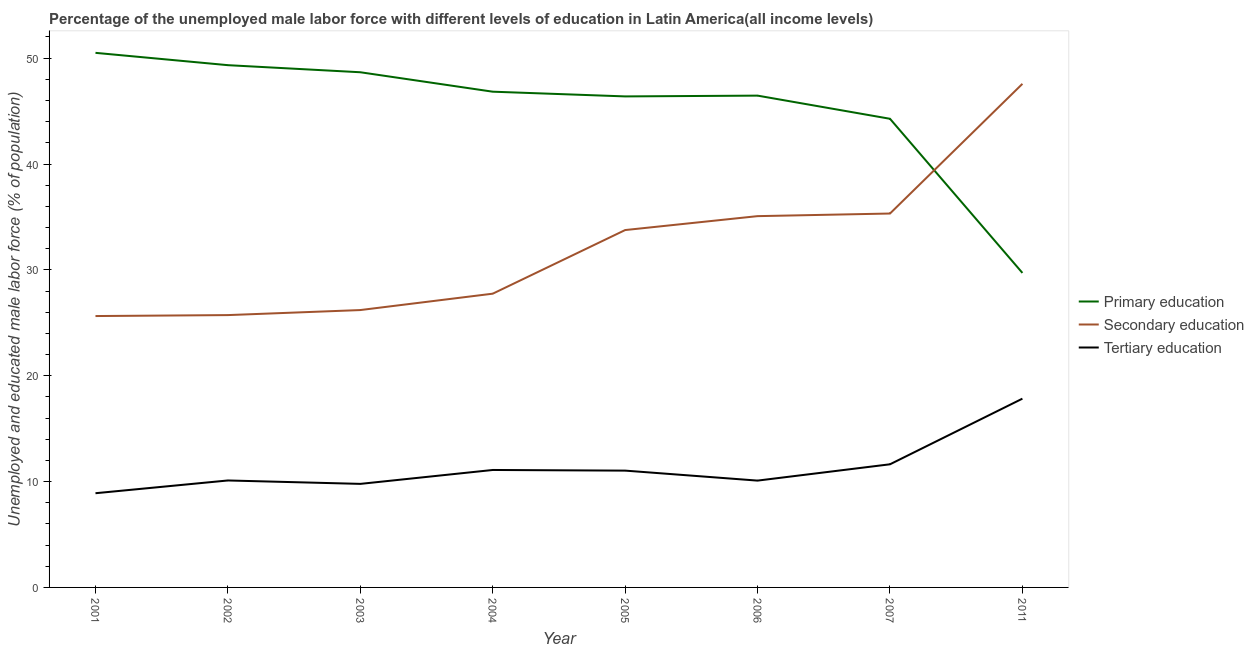How many different coloured lines are there?
Ensure brevity in your answer.  3. Does the line corresponding to percentage of male labor force who received primary education intersect with the line corresponding to percentage of male labor force who received tertiary education?
Ensure brevity in your answer.  No. Is the number of lines equal to the number of legend labels?
Keep it short and to the point. Yes. What is the percentage of male labor force who received primary education in 2003?
Offer a very short reply. 48.67. Across all years, what is the maximum percentage of male labor force who received secondary education?
Ensure brevity in your answer.  47.57. Across all years, what is the minimum percentage of male labor force who received tertiary education?
Keep it short and to the point. 8.9. In which year was the percentage of male labor force who received primary education minimum?
Offer a terse response. 2011. What is the total percentage of male labor force who received primary education in the graph?
Provide a short and direct response. 362.17. What is the difference between the percentage of male labor force who received tertiary education in 2004 and that in 2011?
Provide a succinct answer. -6.74. What is the difference between the percentage of male labor force who received tertiary education in 2007 and the percentage of male labor force who received secondary education in 2004?
Your response must be concise. -16.12. What is the average percentage of male labor force who received secondary education per year?
Give a very brief answer. 32.13. In the year 2004, what is the difference between the percentage of male labor force who received tertiary education and percentage of male labor force who received primary education?
Your answer should be very brief. -35.74. In how many years, is the percentage of male labor force who received tertiary education greater than 26 %?
Provide a short and direct response. 0. What is the ratio of the percentage of male labor force who received secondary education in 2003 to that in 2004?
Offer a very short reply. 0.94. Is the percentage of male labor force who received secondary education in 2002 less than that in 2004?
Provide a short and direct response. Yes. What is the difference between the highest and the second highest percentage of male labor force who received primary education?
Your answer should be compact. 1.16. What is the difference between the highest and the lowest percentage of male labor force who received primary education?
Your answer should be compact. 20.79. Is the sum of the percentage of male labor force who received tertiary education in 2002 and 2005 greater than the maximum percentage of male labor force who received secondary education across all years?
Offer a very short reply. No. Is it the case that in every year, the sum of the percentage of male labor force who received primary education and percentage of male labor force who received secondary education is greater than the percentage of male labor force who received tertiary education?
Offer a very short reply. Yes. Is the percentage of male labor force who received secondary education strictly greater than the percentage of male labor force who received primary education over the years?
Your response must be concise. No. Is the percentage of male labor force who received secondary education strictly less than the percentage of male labor force who received primary education over the years?
Offer a very short reply. No. How many years are there in the graph?
Keep it short and to the point. 8. Does the graph contain grids?
Provide a short and direct response. No. How many legend labels are there?
Provide a succinct answer. 3. What is the title of the graph?
Give a very brief answer. Percentage of the unemployed male labor force with different levels of education in Latin America(all income levels). What is the label or title of the X-axis?
Provide a succinct answer. Year. What is the label or title of the Y-axis?
Your answer should be compact. Unemployed and educated male labor force (% of population). What is the Unemployed and educated male labor force (% of population) of Primary education in 2001?
Ensure brevity in your answer.  50.5. What is the Unemployed and educated male labor force (% of population) of Secondary education in 2001?
Your response must be concise. 25.64. What is the Unemployed and educated male labor force (% of population) of Tertiary education in 2001?
Provide a succinct answer. 8.9. What is the Unemployed and educated male labor force (% of population) in Primary education in 2002?
Offer a terse response. 49.34. What is the Unemployed and educated male labor force (% of population) in Secondary education in 2002?
Give a very brief answer. 25.73. What is the Unemployed and educated male labor force (% of population) in Tertiary education in 2002?
Your answer should be very brief. 10.1. What is the Unemployed and educated male labor force (% of population) of Primary education in 2003?
Your answer should be very brief. 48.67. What is the Unemployed and educated male labor force (% of population) of Secondary education in 2003?
Offer a very short reply. 26.2. What is the Unemployed and educated male labor force (% of population) of Tertiary education in 2003?
Ensure brevity in your answer.  9.78. What is the Unemployed and educated male labor force (% of population) of Primary education in 2004?
Your answer should be compact. 46.83. What is the Unemployed and educated male labor force (% of population) in Secondary education in 2004?
Offer a terse response. 27.75. What is the Unemployed and educated male labor force (% of population) of Tertiary education in 2004?
Offer a very short reply. 11.1. What is the Unemployed and educated male labor force (% of population) in Primary education in 2005?
Your answer should be compact. 46.39. What is the Unemployed and educated male labor force (% of population) of Secondary education in 2005?
Give a very brief answer. 33.76. What is the Unemployed and educated male labor force (% of population) in Tertiary education in 2005?
Your answer should be compact. 11.03. What is the Unemployed and educated male labor force (% of population) of Primary education in 2006?
Your answer should be compact. 46.46. What is the Unemployed and educated male labor force (% of population) in Secondary education in 2006?
Your response must be concise. 35.08. What is the Unemployed and educated male labor force (% of population) in Tertiary education in 2006?
Your answer should be compact. 10.09. What is the Unemployed and educated male labor force (% of population) in Primary education in 2007?
Give a very brief answer. 44.27. What is the Unemployed and educated male labor force (% of population) in Secondary education in 2007?
Provide a short and direct response. 35.32. What is the Unemployed and educated male labor force (% of population) in Tertiary education in 2007?
Provide a short and direct response. 11.63. What is the Unemployed and educated male labor force (% of population) in Primary education in 2011?
Your answer should be compact. 29.71. What is the Unemployed and educated male labor force (% of population) of Secondary education in 2011?
Make the answer very short. 47.57. What is the Unemployed and educated male labor force (% of population) of Tertiary education in 2011?
Offer a terse response. 17.83. Across all years, what is the maximum Unemployed and educated male labor force (% of population) of Primary education?
Provide a succinct answer. 50.5. Across all years, what is the maximum Unemployed and educated male labor force (% of population) of Secondary education?
Make the answer very short. 47.57. Across all years, what is the maximum Unemployed and educated male labor force (% of population) in Tertiary education?
Your answer should be very brief. 17.83. Across all years, what is the minimum Unemployed and educated male labor force (% of population) of Primary education?
Ensure brevity in your answer.  29.71. Across all years, what is the minimum Unemployed and educated male labor force (% of population) in Secondary education?
Offer a terse response. 25.64. Across all years, what is the minimum Unemployed and educated male labor force (% of population) of Tertiary education?
Make the answer very short. 8.9. What is the total Unemployed and educated male labor force (% of population) of Primary education in the graph?
Your answer should be compact. 362.17. What is the total Unemployed and educated male labor force (% of population) of Secondary education in the graph?
Offer a very short reply. 257.05. What is the total Unemployed and educated male labor force (% of population) in Tertiary education in the graph?
Provide a succinct answer. 90.47. What is the difference between the Unemployed and educated male labor force (% of population) of Primary education in 2001 and that in 2002?
Ensure brevity in your answer.  1.16. What is the difference between the Unemployed and educated male labor force (% of population) in Secondary education in 2001 and that in 2002?
Offer a very short reply. -0.09. What is the difference between the Unemployed and educated male labor force (% of population) in Tertiary education in 2001 and that in 2002?
Ensure brevity in your answer.  -1.2. What is the difference between the Unemployed and educated male labor force (% of population) in Primary education in 2001 and that in 2003?
Keep it short and to the point. 1.83. What is the difference between the Unemployed and educated male labor force (% of population) in Secondary education in 2001 and that in 2003?
Provide a short and direct response. -0.57. What is the difference between the Unemployed and educated male labor force (% of population) of Tertiary education in 2001 and that in 2003?
Provide a succinct answer. -0.88. What is the difference between the Unemployed and educated male labor force (% of population) of Primary education in 2001 and that in 2004?
Give a very brief answer. 3.67. What is the difference between the Unemployed and educated male labor force (% of population) in Secondary education in 2001 and that in 2004?
Your response must be concise. -2.11. What is the difference between the Unemployed and educated male labor force (% of population) in Tertiary education in 2001 and that in 2004?
Provide a short and direct response. -2.2. What is the difference between the Unemployed and educated male labor force (% of population) of Primary education in 2001 and that in 2005?
Your response must be concise. 4.12. What is the difference between the Unemployed and educated male labor force (% of population) in Secondary education in 2001 and that in 2005?
Your answer should be compact. -8.12. What is the difference between the Unemployed and educated male labor force (% of population) of Tertiary education in 2001 and that in 2005?
Give a very brief answer. -2.13. What is the difference between the Unemployed and educated male labor force (% of population) of Primary education in 2001 and that in 2006?
Keep it short and to the point. 4.04. What is the difference between the Unemployed and educated male labor force (% of population) of Secondary education in 2001 and that in 2006?
Provide a succinct answer. -9.44. What is the difference between the Unemployed and educated male labor force (% of population) of Tertiary education in 2001 and that in 2006?
Your answer should be very brief. -1.19. What is the difference between the Unemployed and educated male labor force (% of population) of Primary education in 2001 and that in 2007?
Ensure brevity in your answer.  6.23. What is the difference between the Unemployed and educated male labor force (% of population) of Secondary education in 2001 and that in 2007?
Your answer should be compact. -9.69. What is the difference between the Unemployed and educated male labor force (% of population) in Tertiary education in 2001 and that in 2007?
Give a very brief answer. -2.73. What is the difference between the Unemployed and educated male labor force (% of population) in Primary education in 2001 and that in 2011?
Give a very brief answer. 20.79. What is the difference between the Unemployed and educated male labor force (% of population) of Secondary education in 2001 and that in 2011?
Provide a short and direct response. -21.94. What is the difference between the Unemployed and educated male labor force (% of population) in Tertiary education in 2001 and that in 2011?
Ensure brevity in your answer.  -8.93. What is the difference between the Unemployed and educated male labor force (% of population) of Primary education in 2002 and that in 2003?
Your answer should be very brief. 0.67. What is the difference between the Unemployed and educated male labor force (% of population) of Secondary education in 2002 and that in 2003?
Provide a succinct answer. -0.48. What is the difference between the Unemployed and educated male labor force (% of population) in Tertiary education in 2002 and that in 2003?
Give a very brief answer. 0.32. What is the difference between the Unemployed and educated male labor force (% of population) of Primary education in 2002 and that in 2004?
Your answer should be very brief. 2.51. What is the difference between the Unemployed and educated male labor force (% of population) of Secondary education in 2002 and that in 2004?
Keep it short and to the point. -2.02. What is the difference between the Unemployed and educated male labor force (% of population) of Tertiary education in 2002 and that in 2004?
Your answer should be very brief. -0.99. What is the difference between the Unemployed and educated male labor force (% of population) of Primary education in 2002 and that in 2005?
Ensure brevity in your answer.  2.95. What is the difference between the Unemployed and educated male labor force (% of population) in Secondary education in 2002 and that in 2005?
Give a very brief answer. -8.03. What is the difference between the Unemployed and educated male labor force (% of population) in Tertiary education in 2002 and that in 2005?
Ensure brevity in your answer.  -0.93. What is the difference between the Unemployed and educated male labor force (% of population) of Primary education in 2002 and that in 2006?
Your answer should be compact. 2.88. What is the difference between the Unemployed and educated male labor force (% of population) in Secondary education in 2002 and that in 2006?
Your answer should be very brief. -9.35. What is the difference between the Unemployed and educated male labor force (% of population) in Tertiary education in 2002 and that in 2006?
Provide a succinct answer. 0.01. What is the difference between the Unemployed and educated male labor force (% of population) in Primary education in 2002 and that in 2007?
Offer a terse response. 5.06. What is the difference between the Unemployed and educated male labor force (% of population) of Secondary education in 2002 and that in 2007?
Keep it short and to the point. -9.59. What is the difference between the Unemployed and educated male labor force (% of population) of Tertiary education in 2002 and that in 2007?
Provide a succinct answer. -1.53. What is the difference between the Unemployed and educated male labor force (% of population) of Primary education in 2002 and that in 2011?
Keep it short and to the point. 19.63. What is the difference between the Unemployed and educated male labor force (% of population) of Secondary education in 2002 and that in 2011?
Give a very brief answer. -21.85. What is the difference between the Unemployed and educated male labor force (% of population) in Tertiary education in 2002 and that in 2011?
Ensure brevity in your answer.  -7.73. What is the difference between the Unemployed and educated male labor force (% of population) of Primary education in 2003 and that in 2004?
Provide a short and direct response. 1.84. What is the difference between the Unemployed and educated male labor force (% of population) of Secondary education in 2003 and that in 2004?
Your answer should be compact. -1.55. What is the difference between the Unemployed and educated male labor force (% of population) of Tertiary education in 2003 and that in 2004?
Your response must be concise. -1.31. What is the difference between the Unemployed and educated male labor force (% of population) in Primary education in 2003 and that in 2005?
Offer a terse response. 2.28. What is the difference between the Unemployed and educated male labor force (% of population) of Secondary education in 2003 and that in 2005?
Offer a very short reply. -7.56. What is the difference between the Unemployed and educated male labor force (% of population) in Tertiary education in 2003 and that in 2005?
Ensure brevity in your answer.  -1.25. What is the difference between the Unemployed and educated male labor force (% of population) in Primary education in 2003 and that in 2006?
Your answer should be compact. 2.21. What is the difference between the Unemployed and educated male labor force (% of population) of Secondary education in 2003 and that in 2006?
Your answer should be compact. -8.87. What is the difference between the Unemployed and educated male labor force (% of population) in Tertiary education in 2003 and that in 2006?
Provide a short and direct response. -0.31. What is the difference between the Unemployed and educated male labor force (% of population) of Primary education in 2003 and that in 2007?
Your response must be concise. 4.4. What is the difference between the Unemployed and educated male labor force (% of population) of Secondary education in 2003 and that in 2007?
Ensure brevity in your answer.  -9.12. What is the difference between the Unemployed and educated male labor force (% of population) in Tertiary education in 2003 and that in 2007?
Your response must be concise. -1.85. What is the difference between the Unemployed and educated male labor force (% of population) of Primary education in 2003 and that in 2011?
Provide a succinct answer. 18.96. What is the difference between the Unemployed and educated male labor force (% of population) in Secondary education in 2003 and that in 2011?
Your answer should be very brief. -21.37. What is the difference between the Unemployed and educated male labor force (% of population) of Tertiary education in 2003 and that in 2011?
Provide a succinct answer. -8.05. What is the difference between the Unemployed and educated male labor force (% of population) of Primary education in 2004 and that in 2005?
Give a very brief answer. 0.45. What is the difference between the Unemployed and educated male labor force (% of population) of Secondary education in 2004 and that in 2005?
Provide a succinct answer. -6.01. What is the difference between the Unemployed and educated male labor force (% of population) in Tertiary education in 2004 and that in 2005?
Keep it short and to the point. 0.06. What is the difference between the Unemployed and educated male labor force (% of population) of Primary education in 2004 and that in 2006?
Offer a very short reply. 0.37. What is the difference between the Unemployed and educated male labor force (% of population) of Secondary education in 2004 and that in 2006?
Provide a succinct answer. -7.33. What is the difference between the Unemployed and educated male labor force (% of population) of Primary education in 2004 and that in 2007?
Your response must be concise. 2.56. What is the difference between the Unemployed and educated male labor force (% of population) in Secondary education in 2004 and that in 2007?
Your answer should be compact. -7.57. What is the difference between the Unemployed and educated male labor force (% of population) of Tertiary education in 2004 and that in 2007?
Make the answer very short. -0.54. What is the difference between the Unemployed and educated male labor force (% of population) of Primary education in 2004 and that in 2011?
Give a very brief answer. 17.12. What is the difference between the Unemployed and educated male labor force (% of population) of Secondary education in 2004 and that in 2011?
Your answer should be very brief. -19.82. What is the difference between the Unemployed and educated male labor force (% of population) of Tertiary education in 2004 and that in 2011?
Your response must be concise. -6.74. What is the difference between the Unemployed and educated male labor force (% of population) in Primary education in 2005 and that in 2006?
Provide a short and direct response. -0.07. What is the difference between the Unemployed and educated male labor force (% of population) of Secondary education in 2005 and that in 2006?
Offer a very short reply. -1.32. What is the difference between the Unemployed and educated male labor force (% of population) of Tertiary education in 2005 and that in 2006?
Make the answer very short. 0.94. What is the difference between the Unemployed and educated male labor force (% of population) in Primary education in 2005 and that in 2007?
Provide a succinct answer. 2.11. What is the difference between the Unemployed and educated male labor force (% of population) in Secondary education in 2005 and that in 2007?
Provide a short and direct response. -1.56. What is the difference between the Unemployed and educated male labor force (% of population) in Tertiary education in 2005 and that in 2007?
Your response must be concise. -0.6. What is the difference between the Unemployed and educated male labor force (% of population) of Primary education in 2005 and that in 2011?
Your response must be concise. 16.67. What is the difference between the Unemployed and educated male labor force (% of population) in Secondary education in 2005 and that in 2011?
Offer a very short reply. -13.81. What is the difference between the Unemployed and educated male labor force (% of population) in Tertiary education in 2005 and that in 2011?
Provide a short and direct response. -6.8. What is the difference between the Unemployed and educated male labor force (% of population) of Primary education in 2006 and that in 2007?
Your answer should be very brief. 2.19. What is the difference between the Unemployed and educated male labor force (% of population) of Secondary education in 2006 and that in 2007?
Offer a terse response. -0.25. What is the difference between the Unemployed and educated male labor force (% of population) of Tertiary education in 2006 and that in 2007?
Your answer should be very brief. -1.54. What is the difference between the Unemployed and educated male labor force (% of population) in Primary education in 2006 and that in 2011?
Provide a short and direct response. 16.75. What is the difference between the Unemployed and educated male labor force (% of population) in Secondary education in 2006 and that in 2011?
Your response must be concise. -12.5. What is the difference between the Unemployed and educated male labor force (% of population) in Tertiary education in 2006 and that in 2011?
Keep it short and to the point. -7.74. What is the difference between the Unemployed and educated male labor force (% of population) of Primary education in 2007 and that in 2011?
Make the answer very short. 14.56. What is the difference between the Unemployed and educated male labor force (% of population) of Secondary education in 2007 and that in 2011?
Give a very brief answer. -12.25. What is the difference between the Unemployed and educated male labor force (% of population) in Tertiary education in 2007 and that in 2011?
Your answer should be very brief. -6.2. What is the difference between the Unemployed and educated male labor force (% of population) in Primary education in 2001 and the Unemployed and educated male labor force (% of population) in Secondary education in 2002?
Provide a succinct answer. 24.77. What is the difference between the Unemployed and educated male labor force (% of population) of Primary education in 2001 and the Unemployed and educated male labor force (% of population) of Tertiary education in 2002?
Your response must be concise. 40.4. What is the difference between the Unemployed and educated male labor force (% of population) of Secondary education in 2001 and the Unemployed and educated male labor force (% of population) of Tertiary education in 2002?
Your response must be concise. 15.53. What is the difference between the Unemployed and educated male labor force (% of population) in Primary education in 2001 and the Unemployed and educated male labor force (% of population) in Secondary education in 2003?
Offer a terse response. 24.3. What is the difference between the Unemployed and educated male labor force (% of population) in Primary education in 2001 and the Unemployed and educated male labor force (% of population) in Tertiary education in 2003?
Ensure brevity in your answer.  40.72. What is the difference between the Unemployed and educated male labor force (% of population) in Secondary education in 2001 and the Unemployed and educated male labor force (% of population) in Tertiary education in 2003?
Ensure brevity in your answer.  15.86. What is the difference between the Unemployed and educated male labor force (% of population) of Primary education in 2001 and the Unemployed and educated male labor force (% of population) of Secondary education in 2004?
Offer a terse response. 22.75. What is the difference between the Unemployed and educated male labor force (% of population) of Primary education in 2001 and the Unemployed and educated male labor force (% of population) of Tertiary education in 2004?
Make the answer very short. 39.41. What is the difference between the Unemployed and educated male labor force (% of population) of Secondary education in 2001 and the Unemployed and educated male labor force (% of population) of Tertiary education in 2004?
Provide a succinct answer. 14.54. What is the difference between the Unemployed and educated male labor force (% of population) in Primary education in 2001 and the Unemployed and educated male labor force (% of population) in Secondary education in 2005?
Ensure brevity in your answer.  16.74. What is the difference between the Unemployed and educated male labor force (% of population) in Primary education in 2001 and the Unemployed and educated male labor force (% of population) in Tertiary education in 2005?
Make the answer very short. 39.47. What is the difference between the Unemployed and educated male labor force (% of population) of Secondary education in 2001 and the Unemployed and educated male labor force (% of population) of Tertiary education in 2005?
Give a very brief answer. 14.6. What is the difference between the Unemployed and educated male labor force (% of population) of Primary education in 2001 and the Unemployed and educated male labor force (% of population) of Secondary education in 2006?
Your answer should be very brief. 15.43. What is the difference between the Unemployed and educated male labor force (% of population) in Primary education in 2001 and the Unemployed and educated male labor force (% of population) in Tertiary education in 2006?
Keep it short and to the point. 40.41. What is the difference between the Unemployed and educated male labor force (% of population) in Secondary education in 2001 and the Unemployed and educated male labor force (% of population) in Tertiary education in 2006?
Make the answer very short. 15.55. What is the difference between the Unemployed and educated male labor force (% of population) in Primary education in 2001 and the Unemployed and educated male labor force (% of population) in Secondary education in 2007?
Your answer should be very brief. 15.18. What is the difference between the Unemployed and educated male labor force (% of population) in Primary education in 2001 and the Unemployed and educated male labor force (% of population) in Tertiary education in 2007?
Your response must be concise. 38.87. What is the difference between the Unemployed and educated male labor force (% of population) of Secondary education in 2001 and the Unemployed and educated male labor force (% of population) of Tertiary education in 2007?
Your answer should be very brief. 14.01. What is the difference between the Unemployed and educated male labor force (% of population) in Primary education in 2001 and the Unemployed and educated male labor force (% of population) in Secondary education in 2011?
Your answer should be very brief. 2.93. What is the difference between the Unemployed and educated male labor force (% of population) of Primary education in 2001 and the Unemployed and educated male labor force (% of population) of Tertiary education in 2011?
Offer a terse response. 32.67. What is the difference between the Unemployed and educated male labor force (% of population) of Secondary education in 2001 and the Unemployed and educated male labor force (% of population) of Tertiary education in 2011?
Your answer should be compact. 7.8. What is the difference between the Unemployed and educated male labor force (% of population) in Primary education in 2002 and the Unemployed and educated male labor force (% of population) in Secondary education in 2003?
Offer a very short reply. 23.13. What is the difference between the Unemployed and educated male labor force (% of population) of Primary education in 2002 and the Unemployed and educated male labor force (% of population) of Tertiary education in 2003?
Give a very brief answer. 39.56. What is the difference between the Unemployed and educated male labor force (% of population) of Secondary education in 2002 and the Unemployed and educated male labor force (% of population) of Tertiary education in 2003?
Your answer should be compact. 15.95. What is the difference between the Unemployed and educated male labor force (% of population) of Primary education in 2002 and the Unemployed and educated male labor force (% of population) of Secondary education in 2004?
Provide a short and direct response. 21.59. What is the difference between the Unemployed and educated male labor force (% of population) of Primary education in 2002 and the Unemployed and educated male labor force (% of population) of Tertiary education in 2004?
Your answer should be compact. 38.24. What is the difference between the Unemployed and educated male labor force (% of population) of Secondary education in 2002 and the Unemployed and educated male labor force (% of population) of Tertiary education in 2004?
Your answer should be very brief. 14.63. What is the difference between the Unemployed and educated male labor force (% of population) of Primary education in 2002 and the Unemployed and educated male labor force (% of population) of Secondary education in 2005?
Offer a very short reply. 15.58. What is the difference between the Unemployed and educated male labor force (% of population) of Primary education in 2002 and the Unemployed and educated male labor force (% of population) of Tertiary education in 2005?
Make the answer very short. 38.3. What is the difference between the Unemployed and educated male labor force (% of population) of Secondary education in 2002 and the Unemployed and educated male labor force (% of population) of Tertiary education in 2005?
Your answer should be very brief. 14.69. What is the difference between the Unemployed and educated male labor force (% of population) of Primary education in 2002 and the Unemployed and educated male labor force (% of population) of Secondary education in 2006?
Ensure brevity in your answer.  14.26. What is the difference between the Unemployed and educated male labor force (% of population) in Primary education in 2002 and the Unemployed and educated male labor force (% of population) in Tertiary education in 2006?
Your answer should be compact. 39.25. What is the difference between the Unemployed and educated male labor force (% of population) of Secondary education in 2002 and the Unemployed and educated male labor force (% of population) of Tertiary education in 2006?
Offer a very short reply. 15.64. What is the difference between the Unemployed and educated male labor force (% of population) of Primary education in 2002 and the Unemployed and educated male labor force (% of population) of Secondary education in 2007?
Provide a short and direct response. 14.02. What is the difference between the Unemployed and educated male labor force (% of population) in Primary education in 2002 and the Unemployed and educated male labor force (% of population) in Tertiary education in 2007?
Keep it short and to the point. 37.71. What is the difference between the Unemployed and educated male labor force (% of population) of Secondary education in 2002 and the Unemployed and educated male labor force (% of population) of Tertiary education in 2007?
Make the answer very short. 14.1. What is the difference between the Unemployed and educated male labor force (% of population) in Primary education in 2002 and the Unemployed and educated male labor force (% of population) in Secondary education in 2011?
Offer a terse response. 1.76. What is the difference between the Unemployed and educated male labor force (% of population) in Primary education in 2002 and the Unemployed and educated male labor force (% of population) in Tertiary education in 2011?
Offer a terse response. 31.5. What is the difference between the Unemployed and educated male labor force (% of population) in Secondary education in 2002 and the Unemployed and educated male labor force (% of population) in Tertiary education in 2011?
Your answer should be very brief. 7.89. What is the difference between the Unemployed and educated male labor force (% of population) of Primary education in 2003 and the Unemployed and educated male labor force (% of population) of Secondary education in 2004?
Offer a very short reply. 20.92. What is the difference between the Unemployed and educated male labor force (% of population) of Primary education in 2003 and the Unemployed and educated male labor force (% of population) of Tertiary education in 2004?
Your response must be concise. 37.57. What is the difference between the Unemployed and educated male labor force (% of population) of Secondary education in 2003 and the Unemployed and educated male labor force (% of population) of Tertiary education in 2004?
Provide a short and direct response. 15.11. What is the difference between the Unemployed and educated male labor force (% of population) in Primary education in 2003 and the Unemployed and educated male labor force (% of population) in Secondary education in 2005?
Your response must be concise. 14.91. What is the difference between the Unemployed and educated male labor force (% of population) of Primary education in 2003 and the Unemployed and educated male labor force (% of population) of Tertiary education in 2005?
Your answer should be very brief. 37.63. What is the difference between the Unemployed and educated male labor force (% of population) in Secondary education in 2003 and the Unemployed and educated male labor force (% of population) in Tertiary education in 2005?
Your answer should be compact. 15.17. What is the difference between the Unemployed and educated male labor force (% of population) of Primary education in 2003 and the Unemployed and educated male labor force (% of population) of Secondary education in 2006?
Make the answer very short. 13.59. What is the difference between the Unemployed and educated male labor force (% of population) of Primary education in 2003 and the Unemployed and educated male labor force (% of population) of Tertiary education in 2006?
Offer a very short reply. 38.58. What is the difference between the Unemployed and educated male labor force (% of population) of Secondary education in 2003 and the Unemployed and educated male labor force (% of population) of Tertiary education in 2006?
Provide a short and direct response. 16.11. What is the difference between the Unemployed and educated male labor force (% of population) in Primary education in 2003 and the Unemployed and educated male labor force (% of population) in Secondary education in 2007?
Your answer should be compact. 13.35. What is the difference between the Unemployed and educated male labor force (% of population) in Primary education in 2003 and the Unemployed and educated male labor force (% of population) in Tertiary education in 2007?
Make the answer very short. 37.04. What is the difference between the Unemployed and educated male labor force (% of population) in Secondary education in 2003 and the Unemployed and educated male labor force (% of population) in Tertiary education in 2007?
Your answer should be very brief. 14.57. What is the difference between the Unemployed and educated male labor force (% of population) of Primary education in 2003 and the Unemployed and educated male labor force (% of population) of Secondary education in 2011?
Provide a short and direct response. 1.09. What is the difference between the Unemployed and educated male labor force (% of population) in Primary education in 2003 and the Unemployed and educated male labor force (% of population) in Tertiary education in 2011?
Make the answer very short. 30.84. What is the difference between the Unemployed and educated male labor force (% of population) of Secondary education in 2003 and the Unemployed and educated male labor force (% of population) of Tertiary education in 2011?
Offer a terse response. 8.37. What is the difference between the Unemployed and educated male labor force (% of population) of Primary education in 2004 and the Unemployed and educated male labor force (% of population) of Secondary education in 2005?
Offer a very short reply. 13.07. What is the difference between the Unemployed and educated male labor force (% of population) of Primary education in 2004 and the Unemployed and educated male labor force (% of population) of Tertiary education in 2005?
Your answer should be compact. 35.8. What is the difference between the Unemployed and educated male labor force (% of population) of Secondary education in 2004 and the Unemployed and educated male labor force (% of population) of Tertiary education in 2005?
Ensure brevity in your answer.  16.71. What is the difference between the Unemployed and educated male labor force (% of population) in Primary education in 2004 and the Unemployed and educated male labor force (% of population) in Secondary education in 2006?
Give a very brief answer. 11.76. What is the difference between the Unemployed and educated male labor force (% of population) in Primary education in 2004 and the Unemployed and educated male labor force (% of population) in Tertiary education in 2006?
Keep it short and to the point. 36.74. What is the difference between the Unemployed and educated male labor force (% of population) in Secondary education in 2004 and the Unemployed and educated male labor force (% of population) in Tertiary education in 2006?
Offer a very short reply. 17.66. What is the difference between the Unemployed and educated male labor force (% of population) in Primary education in 2004 and the Unemployed and educated male labor force (% of population) in Secondary education in 2007?
Your answer should be compact. 11.51. What is the difference between the Unemployed and educated male labor force (% of population) in Primary education in 2004 and the Unemployed and educated male labor force (% of population) in Tertiary education in 2007?
Provide a short and direct response. 35.2. What is the difference between the Unemployed and educated male labor force (% of population) in Secondary education in 2004 and the Unemployed and educated male labor force (% of population) in Tertiary education in 2007?
Ensure brevity in your answer.  16.12. What is the difference between the Unemployed and educated male labor force (% of population) of Primary education in 2004 and the Unemployed and educated male labor force (% of population) of Secondary education in 2011?
Your response must be concise. -0.74. What is the difference between the Unemployed and educated male labor force (% of population) of Primary education in 2004 and the Unemployed and educated male labor force (% of population) of Tertiary education in 2011?
Offer a very short reply. 29. What is the difference between the Unemployed and educated male labor force (% of population) in Secondary education in 2004 and the Unemployed and educated male labor force (% of population) in Tertiary education in 2011?
Give a very brief answer. 9.92. What is the difference between the Unemployed and educated male labor force (% of population) in Primary education in 2005 and the Unemployed and educated male labor force (% of population) in Secondary education in 2006?
Your answer should be very brief. 11.31. What is the difference between the Unemployed and educated male labor force (% of population) of Primary education in 2005 and the Unemployed and educated male labor force (% of population) of Tertiary education in 2006?
Keep it short and to the point. 36.3. What is the difference between the Unemployed and educated male labor force (% of population) in Secondary education in 2005 and the Unemployed and educated male labor force (% of population) in Tertiary education in 2006?
Give a very brief answer. 23.67. What is the difference between the Unemployed and educated male labor force (% of population) in Primary education in 2005 and the Unemployed and educated male labor force (% of population) in Secondary education in 2007?
Keep it short and to the point. 11.06. What is the difference between the Unemployed and educated male labor force (% of population) of Primary education in 2005 and the Unemployed and educated male labor force (% of population) of Tertiary education in 2007?
Ensure brevity in your answer.  34.75. What is the difference between the Unemployed and educated male labor force (% of population) in Secondary education in 2005 and the Unemployed and educated male labor force (% of population) in Tertiary education in 2007?
Offer a terse response. 22.13. What is the difference between the Unemployed and educated male labor force (% of population) in Primary education in 2005 and the Unemployed and educated male labor force (% of population) in Secondary education in 2011?
Provide a succinct answer. -1.19. What is the difference between the Unemployed and educated male labor force (% of population) in Primary education in 2005 and the Unemployed and educated male labor force (% of population) in Tertiary education in 2011?
Ensure brevity in your answer.  28.55. What is the difference between the Unemployed and educated male labor force (% of population) of Secondary education in 2005 and the Unemployed and educated male labor force (% of population) of Tertiary education in 2011?
Make the answer very short. 15.93. What is the difference between the Unemployed and educated male labor force (% of population) of Primary education in 2006 and the Unemployed and educated male labor force (% of population) of Secondary education in 2007?
Keep it short and to the point. 11.14. What is the difference between the Unemployed and educated male labor force (% of population) in Primary education in 2006 and the Unemployed and educated male labor force (% of population) in Tertiary education in 2007?
Provide a succinct answer. 34.83. What is the difference between the Unemployed and educated male labor force (% of population) of Secondary education in 2006 and the Unemployed and educated male labor force (% of population) of Tertiary education in 2007?
Offer a very short reply. 23.44. What is the difference between the Unemployed and educated male labor force (% of population) in Primary education in 2006 and the Unemployed and educated male labor force (% of population) in Secondary education in 2011?
Make the answer very short. -1.11. What is the difference between the Unemployed and educated male labor force (% of population) of Primary education in 2006 and the Unemployed and educated male labor force (% of population) of Tertiary education in 2011?
Offer a very short reply. 28.63. What is the difference between the Unemployed and educated male labor force (% of population) of Secondary education in 2006 and the Unemployed and educated male labor force (% of population) of Tertiary education in 2011?
Ensure brevity in your answer.  17.24. What is the difference between the Unemployed and educated male labor force (% of population) of Primary education in 2007 and the Unemployed and educated male labor force (% of population) of Secondary education in 2011?
Offer a very short reply. -3.3. What is the difference between the Unemployed and educated male labor force (% of population) of Primary education in 2007 and the Unemployed and educated male labor force (% of population) of Tertiary education in 2011?
Make the answer very short. 26.44. What is the difference between the Unemployed and educated male labor force (% of population) of Secondary education in 2007 and the Unemployed and educated male labor force (% of population) of Tertiary education in 2011?
Provide a succinct answer. 17.49. What is the average Unemployed and educated male labor force (% of population) in Primary education per year?
Provide a succinct answer. 45.27. What is the average Unemployed and educated male labor force (% of population) in Secondary education per year?
Provide a succinct answer. 32.13. What is the average Unemployed and educated male labor force (% of population) in Tertiary education per year?
Offer a terse response. 11.31. In the year 2001, what is the difference between the Unemployed and educated male labor force (% of population) of Primary education and Unemployed and educated male labor force (% of population) of Secondary education?
Your response must be concise. 24.86. In the year 2001, what is the difference between the Unemployed and educated male labor force (% of population) of Primary education and Unemployed and educated male labor force (% of population) of Tertiary education?
Your answer should be compact. 41.6. In the year 2001, what is the difference between the Unemployed and educated male labor force (% of population) of Secondary education and Unemployed and educated male labor force (% of population) of Tertiary education?
Offer a terse response. 16.74. In the year 2002, what is the difference between the Unemployed and educated male labor force (% of population) of Primary education and Unemployed and educated male labor force (% of population) of Secondary education?
Offer a very short reply. 23.61. In the year 2002, what is the difference between the Unemployed and educated male labor force (% of population) of Primary education and Unemployed and educated male labor force (% of population) of Tertiary education?
Offer a very short reply. 39.23. In the year 2002, what is the difference between the Unemployed and educated male labor force (% of population) in Secondary education and Unemployed and educated male labor force (% of population) in Tertiary education?
Provide a short and direct response. 15.62. In the year 2003, what is the difference between the Unemployed and educated male labor force (% of population) in Primary education and Unemployed and educated male labor force (% of population) in Secondary education?
Offer a terse response. 22.47. In the year 2003, what is the difference between the Unemployed and educated male labor force (% of population) of Primary education and Unemployed and educated male labor force (% of population) of Tertiary education?
Ensure brevity in your answer.  38.89. In the year 2003, what is the difference between the Unemployed and educated male labor force (% of population) in Secondary education and Unemployed and educated male labor force (% of population) in Tertiary education?
Offer a terse response. 16.42. In the year 2004, what is the difference between the Unemployed and educated male labor force (% of population) in Primary education and Unemployed and educated male labor force (% of population) in Secondary education?
Your response must be concise. 19.08. In the year 2004, what is the difference between the Unemployed and educated male labor force (% of population) in Primary education and Unemployed and educated male labor force (% of population) in Tertiary education?
Keep it short and to the point. 35.74. In the year 2004, what is the difference between the Unemployed and educated male labor force (% of population) of Secondary education and Unemployed and educated male labor force (% of population) of Tertiary education?
Provide a succinct answer. 16.65. In the year 2005, what is the difference between the Unemployed and educated male labor force (% of population) in Primary education and Unemployed and educated male labor force (% of population) in Secondary education?
Your response must be concise. 12.63. In the year 2005, what is the difference between the Unemployed and educated male labor force (% of population) in Primary education and Unemployed and educated male labor force (% of population) in Tertiary education?
Offer a terse response. 35.35. In the year 2005, what is the difference between the Unemployed and educated male labor force (% of population) of Secondary education and Unemployed and educated male labor force (% of population) of Tertiary education?
Keep it short and to the point. 22.73. In the year 2006, what is the difference between the Unemployed and educated male labor force (% of population) in Primary education and Unemployed and educated male labor force (% of population) in Secondary education?
Offer a very short reply. 11.38. In the year 2006, what is the difference between the Unemployed and educated male labor force (% of population) of Primary education and Unemployed and educated male labor force (% of population) of Tertiary education?
Keep it short and to the point. 36.37. In the year 2006, what is the difference between the Unemployed and educated male labor force (% of population) in Secondary education and Unemployed and educated male labor force (% of population) in Tertiary education?
Your response must be concise. 24.98. In the year 2007, what is the difference between the Unemployed and educated male labor force (% of population) of Primary education and Unemployed and educated male labor force (% of population) of Secondary education?
Provide a short and direct response. 8.95. In the year 2007, what is the difference between the Unemployed and educated male labor force (% of population) of Primary education and Unemployed and educated male labor force (% of population) of Tertiary education?
Your answer should be compact. 32.64. In the year 2007, what is the difference between the Unemployed and educated male labor force (% of population) in Secondary education and Unemployed and educated male labor force (% of population) in Tertiary education?
Provide a short and direct response. 23.69. In the year 2011, what is the difference between the Unemployed and educated male labor force (% of population) in Primary education and Unemployed and educated male labor force (% of population) in Secondary education?
Provide a succinct answer. -17.86. In the year 2011, what is the difference between the Unemployed and educated male labor force (% of population) in Primary education and Unemployed and educated male labor force (% of population) in Tertiary education?
Ensure brevity in your answer.  11.88. In the year 2011, what is the difference between the Unemployed and educated male labor force (% of population) in Secondary education and Unemployed and educated male labor force (% of population) in Tertiary education?
Your answer should be very brief. 29.74. What is the ratio of the Unemployed and educated male labor force (% of population) of Primary education in 2001 to that in 2002?
Offer a very short reply. 1.02. What is the ratio of the Unemployed and educated male labor force (% of population) in Secondary education in 2001 to that in 2002?
Your answer should be compact. 1. What is the ratio of the Unemployed and educated male labor force (% of population) in Tertiary education in 2001 to that in 2002?
Provide a succinct answer. 0.88. What is the ratio of the Unemployed and educated male labor force (% of population) of Primary education in 2001 to that in 2003?
Your answer should be very brief. 1.04. What is the ratio of the Unemployed and educated male labor force (% of population) of Secondary education in 2001 to that in 2003?
Keep it short and to the point. 0.98. What is the ratio of the Unemployed and educated male labor force (% of population) in Tertiary education in 2001 to that in 2003?
Ensure brevity in your answer.  0.91. What is the ratio of the Unemployed and educated male labor force (% of population) of Primary education in 2001 to that in 2004?
Offer a terse response. 1.08. What is the ratio of the Unemployed and educated male labor force (% of population) in Secondary education in 2001 to that in 2004?
Your answer should be compact. 0.92. What is the ratio of the Unemployed and educated male labor force (% of population) in Tertiary education in 2001 to that in 2004?
Offer a very short reply. 0.8. What is the ratio of the Unemployed and educated male labor force (% of population) of Primary education in 2001 to that in 2005?
Give a very brief answer. 1.09. What is the ratio of the Unemployed and educated male labor force (% of population) in Secondary education in 2001 to that in 2005?
Keep it short and to the point. 0.76. What is the ratio of the Unemployed and educated male labor force (% of population) in Tertiary education in 2001 to that in 2005?
Your answer should be compact. 0.81. What is the ratio of the Unemployed and educated male labor force (% of population) in Primary education in 2001 to that in 2006?
Give a very brief answer. 1.09. What is the ratio of the Unemployed and educated male labor force (% of population) in Secondary education in 2001 to that in 2006?
Offer a very short reply. 0.73. What is the ratio of the Unemployed and educated male labor force (% of population) in Tertiary education in 2001 to that in 2006?
Offer a very short reply. 0.88. What is the ratio of the Unemployed and educated male labor force (% of population) of Primary education in 2001 to that in 2007?
Provide a succinct answer. 1.14. What is the ratio of the Unemployed and educated male labor force (% of population) in Secondary education in 2001 to that in 2007?
Make the answer very short. 0.73. What is the ratio of the Unemployed and educated male labor force (% of population) of Tertiary education in 2001 to that in 2007?
Offer a terse response. 0.77. What is the ratio of the Unemployed and educated male labor force (% of population) in Primary education in 2001 to that in 2011?
Your answer should be very brief. 1.7. What is the ratio of the Unemployed and educated male labor force (% of population) of Secondary education in 2001 to that in 2011?
Give a very brief answer. 0.54. What is the ratio of the Unemployed and educated male labor force (% of population) of Tertiary education in 2001 to that in 2011?
Your response must be concise. 0.5. What is the ratio of the Unemployed and educated male labor force (% of population) of Primary education in 2002 to that in 2003?
Keep it short and to the point. 1.01. What is the ratio of the Unemployed and educated male labor force (% of population) in Secondary education in 2002 to that in 2003?
Make the answer very short. 0.98. What is the ratio of the Unemployed and educated male labor force (% of population) of Tertiary education in 2002 to that in 2003?
Offer a very short reply. 1.03. What is the ratio of the Unemployed and educated male labor force (% of population) of Primary education in 2002 to that in 2004?
Your answer should be very brief. 1.05. What is the ratio of the Unemployed and educated male labor force (% of population) of Secondary education in 2002 to that in 2004?
Your answer should be very brief. 0.93. What is the ratio of the Unemployed and educated male labor force (% of population) in Tertiary education in 2002 to that in 2004?
Offer a terse response. 0.91. What is the ratio of the Unemployed and educated male labor force (% of population) in Primary education in 2002 to that in 2005?
Your response must be concise. 1.06. What is the ratio of the Unemployed and educated male labor force (% of population) in Secondary education in 2002 to that in 2005?
Keep it short and to the point. 0.76. What is the ratio of the Unemployed and educated male labor force (% of population) in Tertiary education in 2002 to that in 2005?
Offer a terse response. 0.92. What is the ratio of the Unemployed and educated male labor force (% of population) in Primary education in 2002 to that in 2006?
Your answer should be very brief. 1.06. What is the ratio of the Unemployed and educated male labor force (% of population) of Secondary education in 2002 to that in 2006?
Make the answer very short. 0.73. What is the ratio of the Unemployed and educated male labor force (% of population) of Primary education in 2002 to that in 2007?
Offer a very short reply. 1.11. What is the ratio of the Unemployed and educated male labor force (% of population) of Secondary education in 2002 to that in 2007?
Your response must be concise. 0.73. What is the ratio of the Unemployed and educated male labor force (% of population) of Tertiary education in 2002 to that in 2007?
Provide a succinct answer. 0.87. What is the ratio of the Unemployed and educated male labor force (% of population) of Primary education in 2002 to that in 2011?
Offer a terse response. 1.66. What is the ratio of the Unemployed and educated male labor force (% of population) in Secondary education in 2002 to that in 2011?
Your answer should be very brief. 0.54. What is the ratio of the Unemployed and educated male labor force (% of population) in Tertiary education in 2002 to that in 2011?
Keep it short and to the point. 0.57. What is the ratio of the Unemployed and educated male labor force (% of population) of Primary education in 2003 to that in 2004?
Your answer should be very brief. 1.04. What is the ratio of the Unemployed and educated male labor force (% of population) in Secondary education in 2003 to that in 2004?
Keep it short and to the point. 0.94. What is the ratio of the Unemployed and educated male labor force (% of population) of Tertiary education in 2003 to that in 2004?
Provide a succinct answer. 0.88. What is the ratio of the Unemployed and educated male labor force (% of population) in Primary education in 2003 to that in 2005?
Give a very brief answer. 1.05. What is the ratio of the Unemployed and educated male labor force (% of population) of Secondary education in 2003 to that in 2005?
Your answer should be very brief. 0.78. What is the ratio of the Unemployed and educated male labor force (% of population) in Tertiary education in 2003 to that in 2005?
Provide a succinct answer. 0.89. What is the ratio of the Unemployed and educated male labor force (% of population) in Primary education in 2003 to that in 2006?
Your response must be concise. 1.05. What is the ratio of the Unemployed and educated male labor force (% of population) in Secondary education in 2003 to that in 2006?
Provide a succinct answer. 0.75. What is the ratio of the Unemployed and educated male labor force (% of population) in Tertiary education in 2003 to that in 2006?
Ensure brevity in your answer.  0.97. What is the ratio of the Unemployed and educated male labor force (% of population) in Primary education in 2003 to that in 2007?
Offer a terse response. 1.1. What is the ratio of the Unemployed and educated male labor force (% of population) in Secondary education in 2003 to that in 2007?
Offer a terse response. 0.74. What is the ratio of the Unemployed and educated male labor force (% of population) of Tertiary education in 2003 to that in 2007?
Keep it short and to the point. 0.84. What is the ratio of the Unemployed and educated male labor force (% of population) in Primary education in 2003 to that in 2011?
Make the answer very short. 1.64. What is the ratio of the Unemployed and educated male labor force (% of population) in Secondary education in 2003 to that in 2011?
Offer a very short reply. 0.55. What is the ratio of the Unemployed and educated male labor force (% of population) in Tertiary education in 2003 to that in 2011?
Provide a short and direct response. 0.55. What is the ratio of the Unemployed and educated male labor force (% of population) in Primary education in 2004 to that in 2005?
Offer a terse response. 1.01. What is the ratio of the Unemployed and educated male labor force (% of population) in Secondary education in 2004 to that in 2005?
Give a very brief answer. 0.82. What is the ratio of the Unemployed and educated male labor force (% of population) in Tertiary education in 2004 to that in 2005?
Your response must be concise. 1.01. What is the ratio of the Unemployed and educated male labor force (% of population) of Secondary education in 2004 to that in 2006?
Keep it short and to the point. 0.79. What is the ratio of the Unemployed and educated male labor force (% of population) in Tertiary education in 2004 to that in 2006?
Provide a short and direct response. 1.1. What is the ratio of the Unemployed and educated male labor force (% of population) in Primary education in 2004 to that in 2007?
Your answer should be very brief. 1.06. What is the ratio of the Unemployed and educated male labor force (% of population) of Secondary education in 2004 to that in 2007?
Give a very brief answer. 0.79. What is the ratio of the Unemployed and educated male labor force (% of population) of Tertiary education in 2004 to that in 2007?
Your answer should be compact. 0.95. What is the ratio of the Unemployed and educated male labor force (% of population) in Primary education in 2004 to that in 2011?
Your response must be concise. 1.58. What is the ratio of the Unemployed and educated male labor force (% of population) in Secondary education in 2004 to that in 2011?
Provide a succinct answer. 0.58. What is the ratio of the Unemployed and educated male labor force (% of population) in Tertiary education in 2004 to that in 2011?
Give a very brief answer. 0.62. What is the ratio of the Unemployed and educated male labor force (% of population) of Primary education in 2005 to that in 2006?
Make the answer very short. 1. What is the ratio of the Unemployed and educated male labor force (% of population) of Secondary education in 2005 to that in 2006?
Make the answer very short. 0.96. What is the ratio of the Unemployed and educated male labor force (% of population) of Tertiary education in 2005 to that in 2006?
Ensure brevity in your answer.  1.09. What is the ratio of the Unemployed and educated male labor force (% of population) in Primary education in 2005 to that in 2007?
Provide a succinct answer. 1.05. What is the ratio of the Unemployed and educated male labor force (% of population) in Secondary education in 2005 to that in 2007?
Provide a short and direct response. 0.96. What is the ratio of the Unemployed and educated male labor force (% of population) of Tertiary education in 2005 to that in 2007?
Offer a very short reply. 0.95. What is the ratio of the Unemployed and educated male labor force (% of population) in Primary education in 2005 to that in 2011?
Provide a short and direct response. 1.56. What is the ratio of the Unemployed and educated male labor force (% of population) in Secondary education in 2005 to that in 2011?
Keep it short and to the point. 0.71. What is the ratio of the Unemployed and educated male labor force (% of population) in Tertiary education in 2005 to that in 2011?
Your answer should be compact. 0.62. What is the ratio of the Unemployed and educated male labor force (% of population) of Primary education in 2006 to that in 2007?
Ensure brevity in your answer.  1.05. What is the ratio of the Unemployed and educated male labor force (% of population) in Secondary education in 2006 to that in 2007?
Offer a terse response. 0.99. What is the ratio of the Unemployed and educated male labor force (% of population) of Tertiary education in 2006 to that in 2007?
Your answer should be compact. 0.87. What is the ratio of the Unemployed and educated male labor force (% of population) of Primary education in 2006 to that in 2011?
Offer a very short reply. 1.56. What is the ratio of the Unemployed and educated male labor force (% of population) in Secondary education in 2006 to that in 2011?
Offer a terse response. 0.74. What is the ratio of the Unemployed and educated male labor force (% of population) in Tertiary education in 2006 to that in 2011?
Your answer should be compact. 0.57. What is the ratio of the Unemployed and educated male labor force (% of population) of Primary education in 2007 to that in 2011?
Make the answer very short. 1.49. What is the ratio of the Unemployed and educated male labor force (% of population) of Secondary education in 2007 to that in 2011?
Offer a terse response. 0.74. What is the ratio of the Unemployed and educated male labor force (% of population) of Tertiary education in 2007 to that in 2011?
Your answer should be compact. 0.65. What is the difference between the highest and the second highest Unemployed and educated male labor force (% of population) of Primary education?
Ensure brevity in your answer.  1.16. What is the difference between the highest and the second highest Unemployed and educated male labor force (% of population) of Secondary education?
Ensure brevity in your answer.  12.25. What is the difference between the highest and the second highest Unemployed and educated male labor force (% of population) in Tertiary education?
Keep it short and to the point. 6.2. What is the difference between the highest and the lowest Unemployed and educated male labor force (% of population) in Primary education?
Give a very brief answer. 20.79. What is the difference between the highest and the lowest Unemployed and educated male labor force (% of population) of Secondary education?
Ensure brevity in your answer.  21.94. What is the difference between the highest and the lowest Unemployed and educated male labor force (% of population) in Tertiary education?
Offer a very short reply. 8.93. 